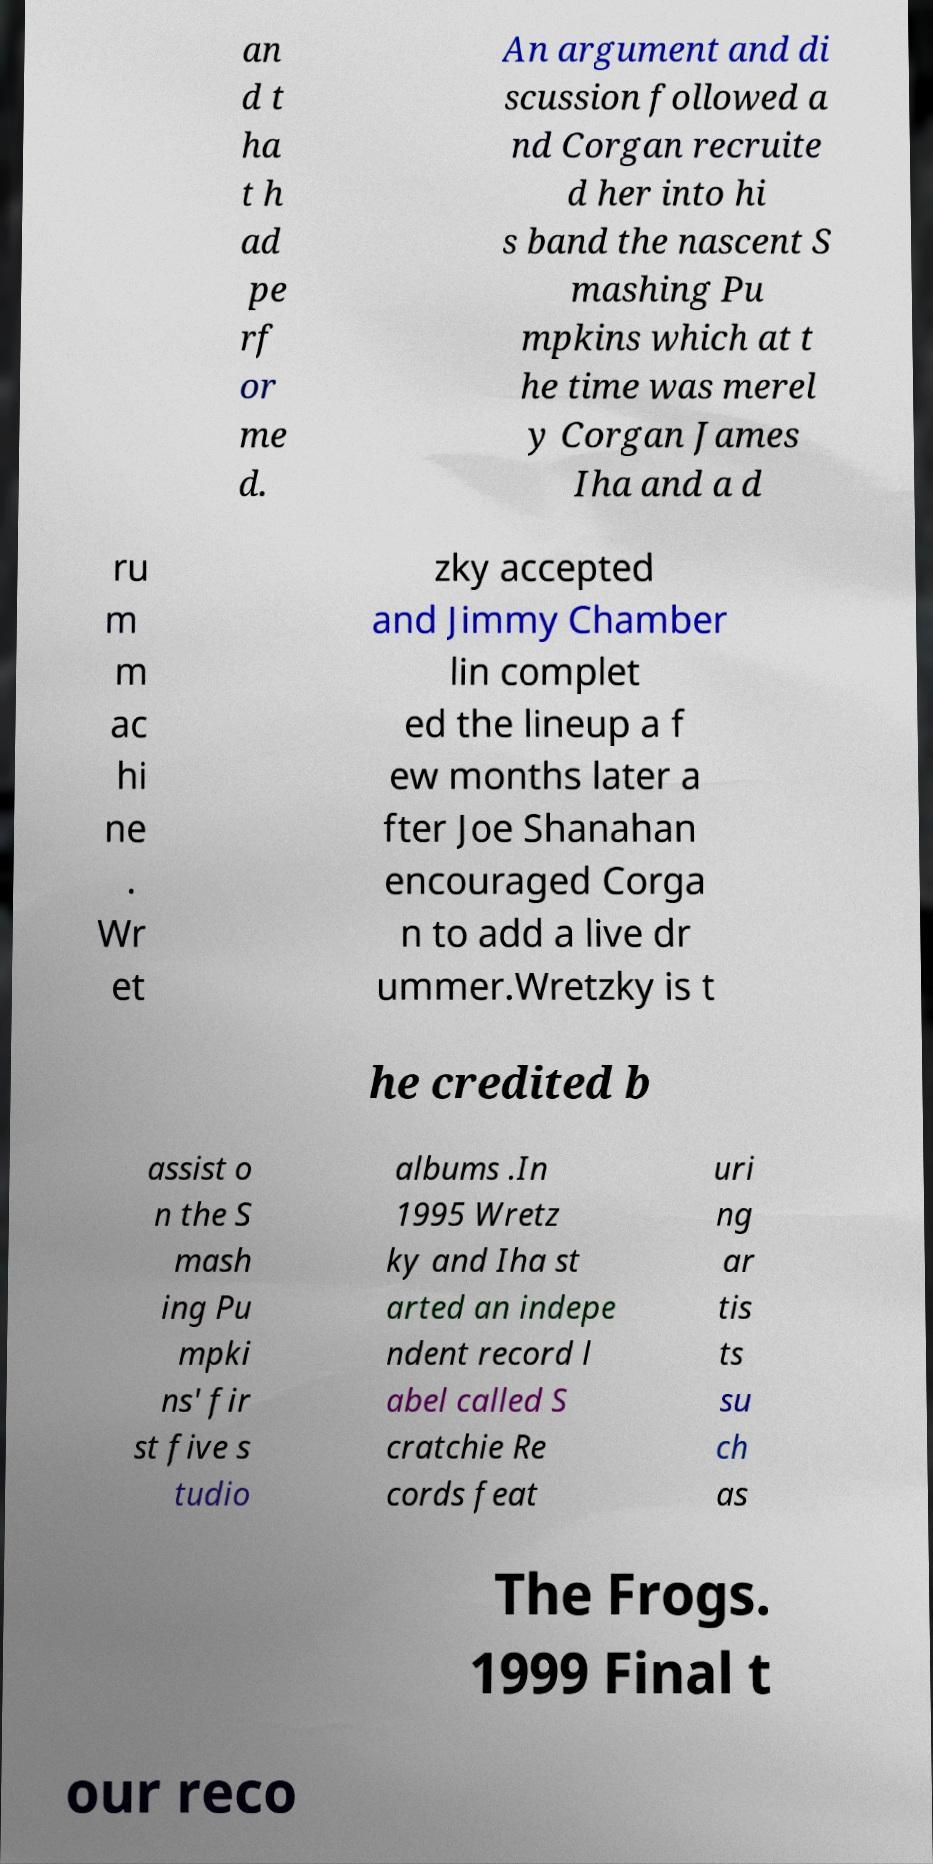Can you accurately transcribe the text from the provided image for me? an d t ha t h ad pe rf or me d. An argument and di scussion followed a nd Corgan recruite d her into hi s band the nascent S mashing Pu mpkins which at t he time was merel y Corgan James Iha and a d ru m m ac hi ne . Wr et zky accepted and Jimmy Chamber lin complet ed the lineup a f ew months later a fter Joe Shanahan encouraged Corga n to add a live dr ummer.Wretzky is t he credited b assist o n the S mash ing Pu mpki ns' fir st five s tudio albums .In 1995 Wretz ky and Iha st arted an indepe ndent record l abel called S cratchie Re cords feat uri ng ar tis ts su ch as The Frogs. 1999 Final t our reco 